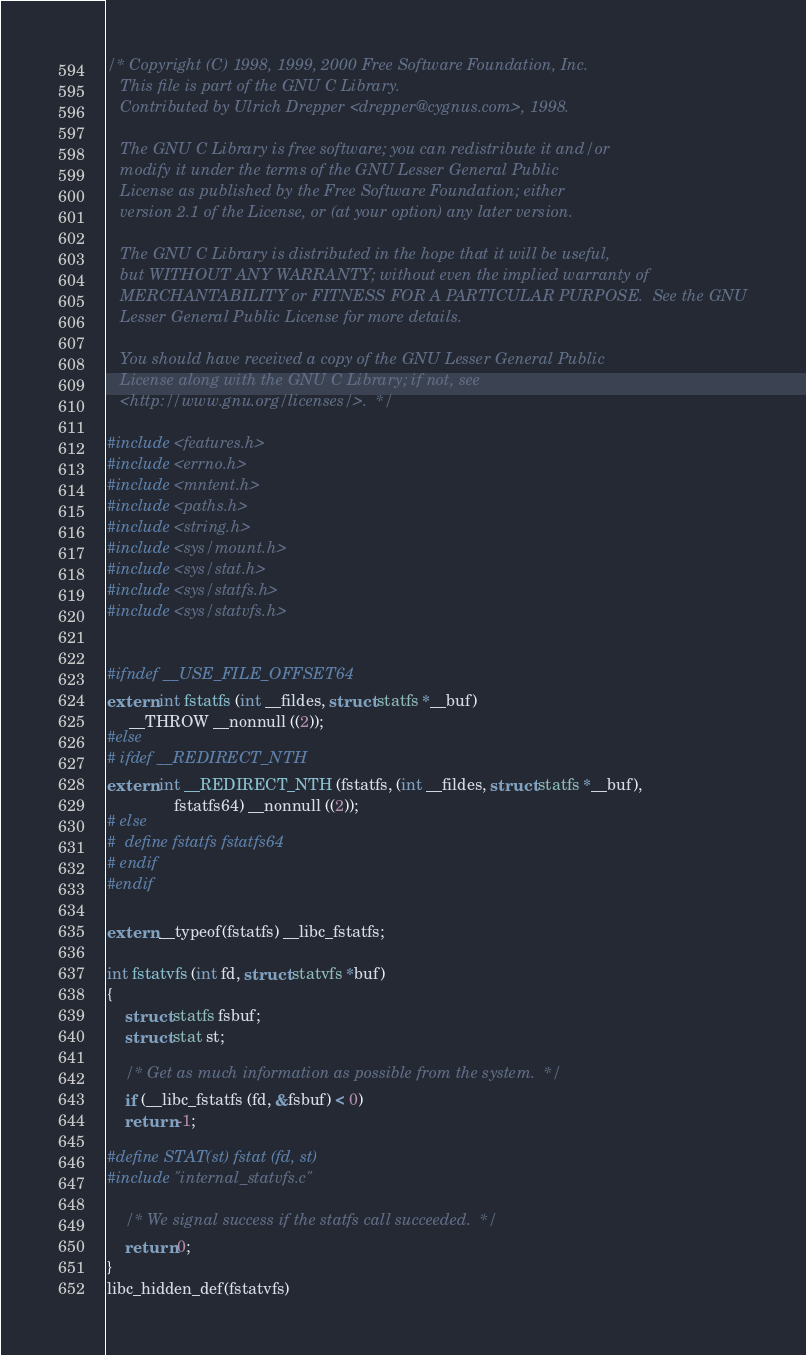Convert code to text. <code><loc_0><loc_0><loc_500><loc_500><_C_>/* Copyright (C) 1998, 1999, 2000 Free Software Foundation, Inc.
   This file is part of the GNU C Library.
   Contributed by Ulrich Drepper <drepper@cygnus.com>, 1998.

   The GNU C Library is free software; you can redistribute it and/or
   modify it under the terms of the GNU Lesser General Public
   License as published by the Free Software Foundation; either
   version 2.1 of the License, or (at your option) any later version.

   The GNU C Library is distributed in the hope that it will be useful,
   but WITHOUT ANY WARRANTY; without even the implied warranty of
   MERCHANTABILITY or FITNESS FOR A PARTICULAR PURPOSE.  See the GNU
   Lesser General Public License for more details.

   You should have received a copy of the GNU Lesser General Public
   License along with the GNU C Library; if not, see
   <http://www.gnu.org/licenses/>.  */

#include <features.h>
#include <errno.h>
#include <mntent.h>
#include <paths.h>
#include <string.h>
#include <sys/mount.h>
#include <sys/stat.h>
#include <sys/statfs.h>
#include <sys/statvfs.h>


#ifndef __USE_FILE_OFFSET64
extern int fstatfs (int __fildes, struct statfs *__buf)
     __THROW __nonnull ((2));
#else
# ifdef __REDIRECT_NTH
extern int __REDIRECT_NTH (fstatfs, (int __fildes, struct statfs *__buf),
			   fstatfs64) __nonnull ((2));
# else
#  define fstatfs fstatfs64
# endif
#endif

extern __typeof(fstatfs) __libc_fstatfs;

int fstatvfs (int fd, struct statvfs *buf)
{
    struct statfs fsbuf;
    struct stat st;

    /* Get as much information as possible from the system.  */
    if (__libc_fstatfs (fd, &fsbuf) < 0)
	return -1;

#define STAT(st) fstat (fd, st)
#include "internal_statvfs.c"

    /* We signal success if the statfs call succeeded.  */
    return 0;
}
libc_hidden_def(fstatvfs)
</code> 